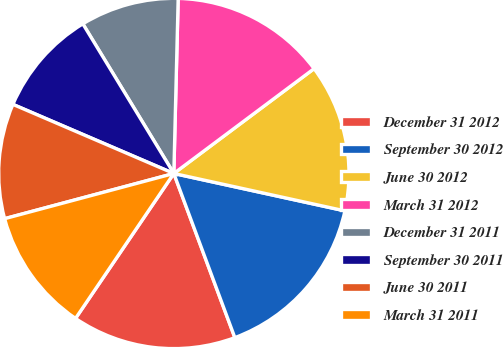Convert chart to OTSL. <chart><loc_0><loc_0><loc_500><loc_500><pie_chart><fcel>December 31 2012<fcel>September 30 2012<fcel>June 30 2012<fcel>March 31 2012<fcel>December 31 2011<fcel>September 30 2011<fcel>June 30 2011<fcel>March 31 2011<nl><fcel>15.15%<fcel>15.91%<fcel>13.64%<fcel>14.39%<fcel>9.09%<fcel>9.85%<fcel>10.61%<fcel>11.36%<nl></chart> 